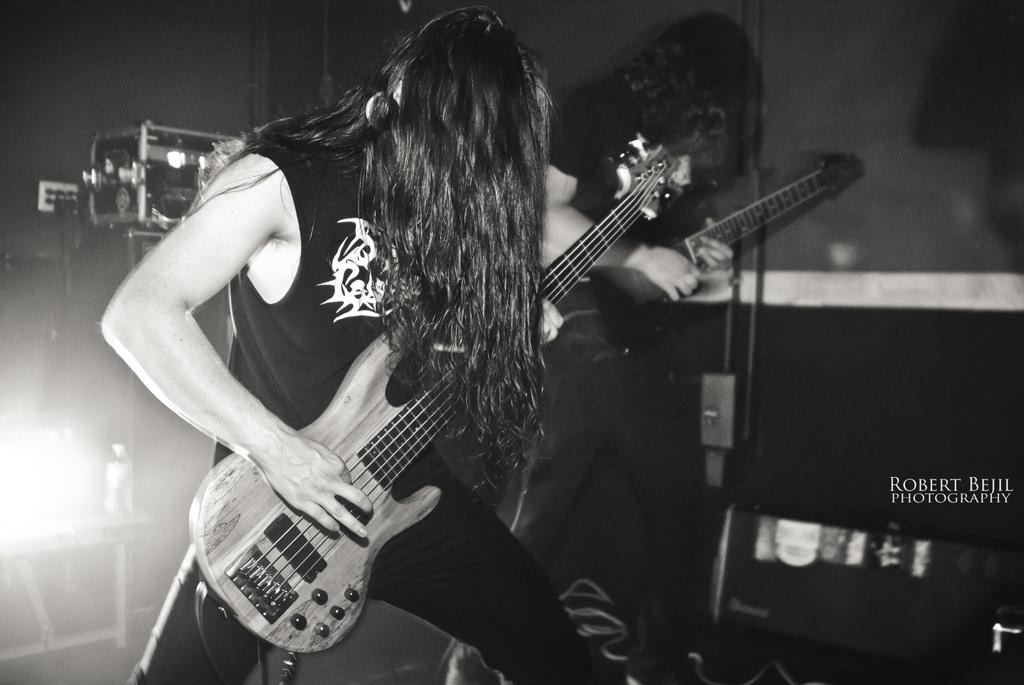How many people are in the image? There are two persons in the image. What are the persons doing in the image? The persons are standing and covering their faces with long hair. What is one of the persons holding in the image? One of the persons is holding a guitar. Where is the light source located in the image? There is a light on the left side of the image. What type of current can be seen flowing through the pigs in the image? There are no pigs present in the image, and therefore no current can be seen flowing through them. 